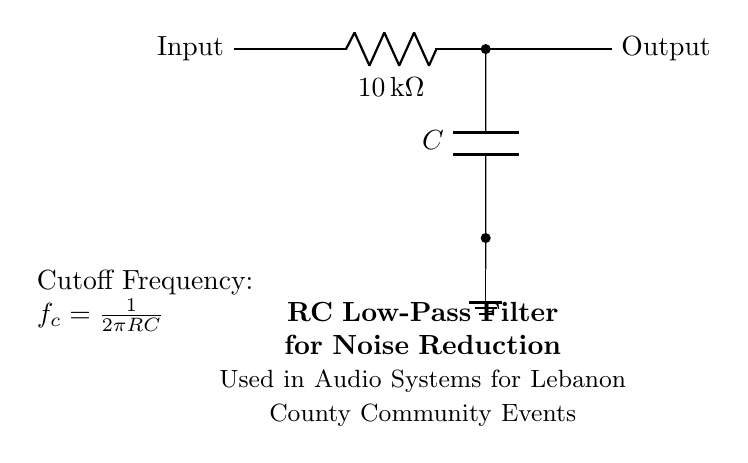What components are used in this circuit? The circuit includes a resistor labeled R and a capacitor labeled C. Both components work together to form an RC filter.
Answer: Resistor and Capacitor What is the value of the resistor used in the circuit? The circuit specifies the resistor value as 10 kilo-ohms, which is indicated next to the R label.
Answer: 10 kilo-ohms What is the purpose of this RC circuit? This RC circuit is primarily used for noise reduction in audio systems, especially during community events, as indicated by the title associated with the diagram.
Answer: Noise reduction How is the cutoff frequency calculated in this circuit? The cutoff frequency is determined using the formula f_c = 1/(2πRC), where R is the resistance and C is the capacitance. This relationship allows for understanding the frequency response of the filter.
Answer: 1/(2πRC) What type of filter is represented by this circuit? The circuit is a low-pass filter, which allows signals with a frequency lower than a certain cutoff frequency to pass through while attenuating higher frequencies.
Answer: Low-pass filter What would happen to signals above the cutoff frequency? Signals above the cutoff frequency will be attenuated, meaning their amplitude decreases, effectively reducing noise in that frequency range. This filtering is crucial for clear audio output.
Answer: Attenuated What is the role of the capacitor in the circuit? The capacitor stores and releases electrical energy, working in conjunction with the resistor to filter out high-frequency noise from the audio signal. It allows low-frequency signals to pass while blocking high frequencies.
Answer: Filtering high frequencies 